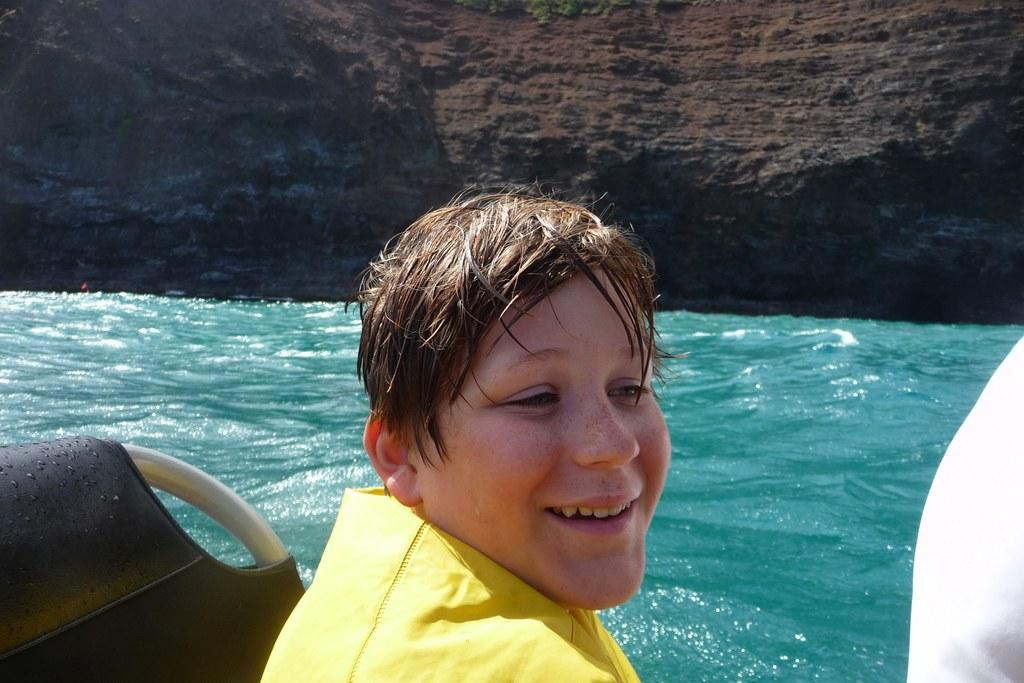Who is in the image? There is a boy in the image. What is the boy wearing? The boy is wearing a yellow t-shirt. Where is the boy located in the image? The boy is sitting on a boat. What can be seen in the background of the image? There is water visible in the image, and there is a hill in the image. What type of drain can be seen in the image? There is no drain present in the image. How many yams are visible in the image? There are no yams present in the image. 